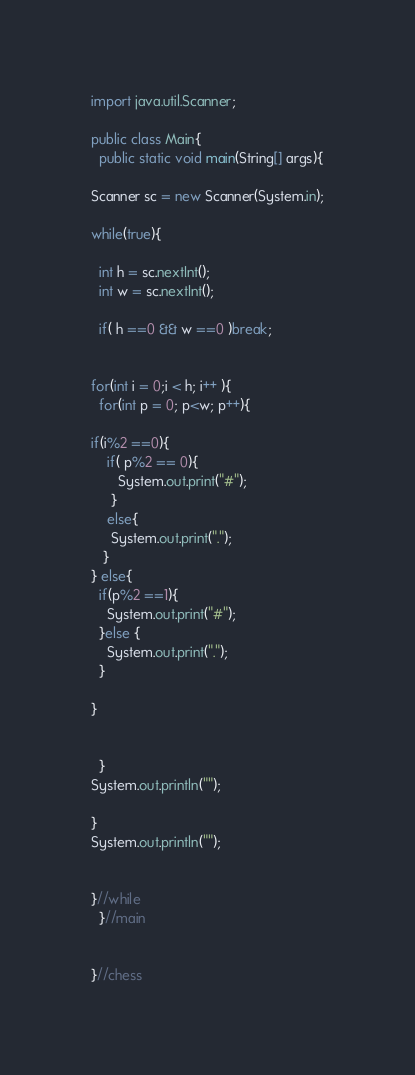Convert code to text. <code><loc_0><loc_0><loc_500><loc_500><_Java_>import java.util.Scanner;

public class Main{
  public static void main(String[] args){

Scanner sc = new Scanner(System.in);

while(true){

  int h = sc.nextInt();
  int w = sc.nextInt();

  if( h ==0 && w ==0 )break;


for(int i = 0;i < h; i++ ){
  for(int p = 0; p<w; p++){

if(i%2 ==0){
    if( p%2 == 0){
       System.out.print("#");
     }
    else{
     System.out.print(".");
   }
} else{
  if(p%2 ==1){
    System.out.print("#");
  }else {
    System.out.print(".");
  }

}


  }
System.out.println("");

}
System.out.println("");


}//while
  }//main


}//chess

</code> 